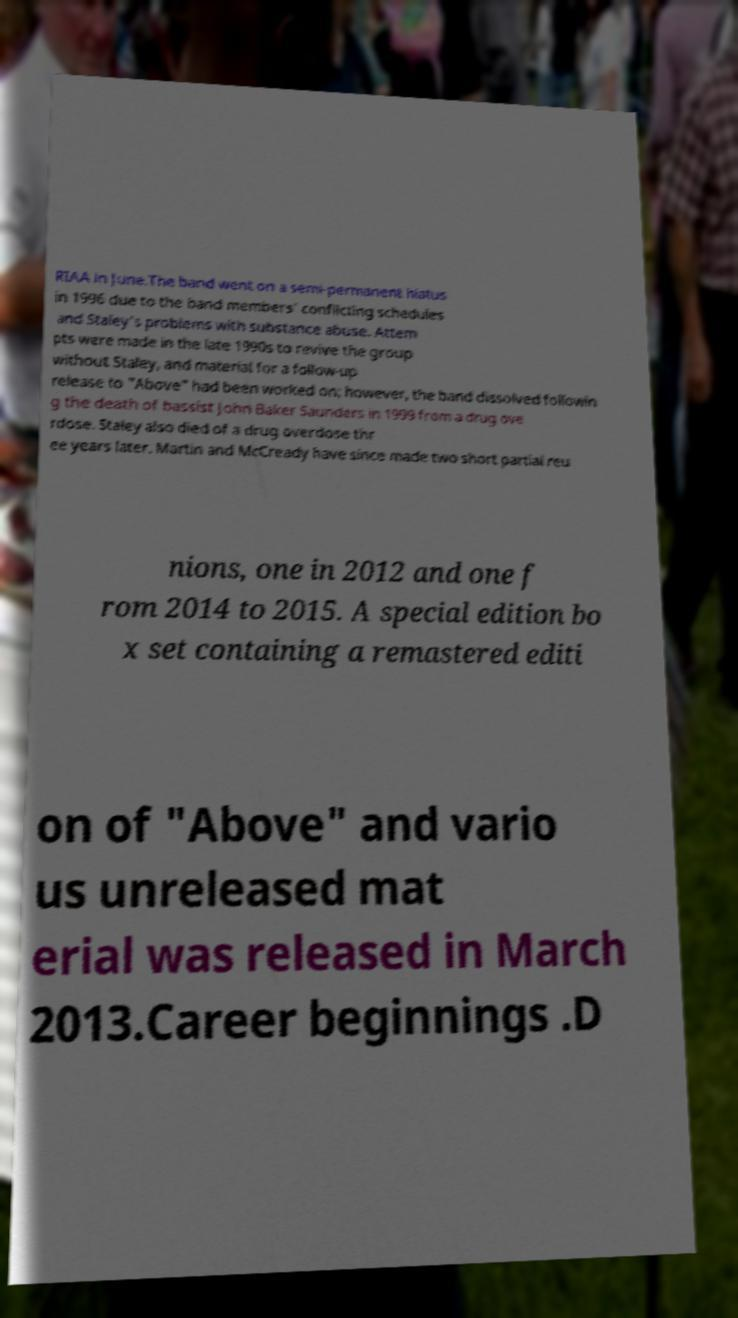For documentation purposes, I need the text within this image transcribed. Could you provide that? RIAA in June.The band went on a semi-permanent hiatus in 1996 due to the band members' conflicting schedules and Staley's problems with substance abuse. Attem pts were made in the late 1990s to revive the group without Staley, and material for a follow-up release to "Above" had been worked on; however, the band dissolved followin g the death of bassist John Baker Saunders in 1999 from a drug ove rdose. Staley also died of a drug overdose thr ee years later. Martin and McCready have since made two short partial reu nions, one in 2012 and one f rom 2014 to 2015. A special edition bo x set containing a remastered editi on of "Above" and vario us unreleased mat erial was released in March 2013.Career beginnings .D 